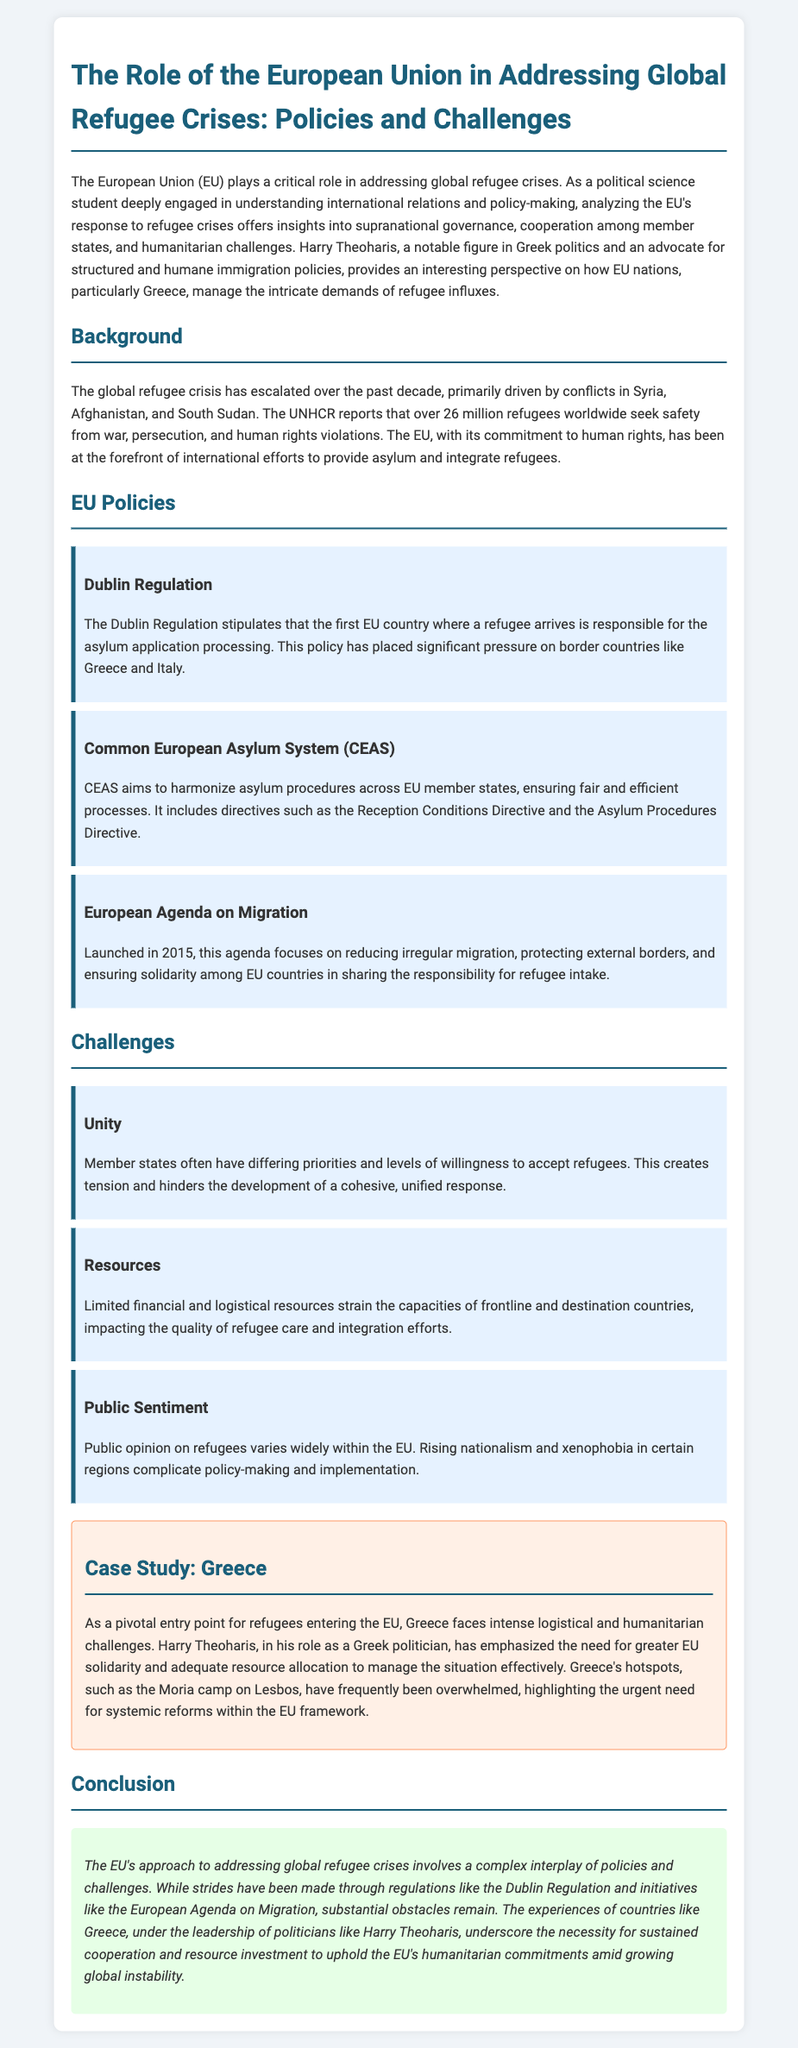what is the main focus of the document? The document discusses the role of the EU in addressing global refugee crises, specifically policies and challenges.
Answer: the role of the EU in addressing global refugee crises how many refugees does the UNHCR report are seeking safety worldwide? The UNHCR reports that over 26 million refugees worldwide seek safety from war, persecution, and human rights violations.
Answer: over 26 million what policy stipulates that the first EU country a refugee arrives in is responsible for the asylum application? This policy is referred to as the Dublin Regulation.
Answer: Dublin Regulation what initiative was launched in 2015 to address irregular migration? The initiative is known as the European Agenda on Migration.
Answer: European Agenda on Migration what is one challenge faced by EU member states regarding refugee acceptance? Member states often have differing priorities and levels of willingness to accept refugees.
Answer: differing priorities who emphasized the need for greater EU solidarity in managing the refugee situation? Harry Theoharis emphasized the need for greater EU solidarity.
Answer: Harry Theoharis what is a significant problem that Greece faces as a frontline country for refugees? Greece faces intense logistical and humanitarian challenges as a pivotal entry point for refugees.
Answer: logistical and humanitarian challenges which EU framework regulation is aimed at harmonizing asylum procedures across member states? The Common European Asylum System (CEAS) is aimed at harmonizing asylum procedures.
Answer: Common European Asylum System (CEAS) what sentiment complicates policy-making and implementation in the EU regarding refugees? Rising nationalism and xenophobia complicate policy-making and implementation.
Answer: nationalism and xenophobia 